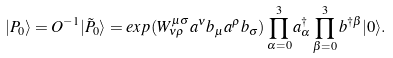Convert formula to latex. <formula><loc_0><loc_0><loc_500><loc_500>| P _ { 0 } \rangle = O ^ { - 1 } | \tilde { P } _ { 0 } \rangle = e x p ( W _ { \nu \rho } ^ { \mu \sigma } a ^ { \nu } b _ { \mu } a ^ { \rho } b _ { \sigma } ) \prod _ { \alpha = 0 } ^ { 3 } a _ { \alpha } ^ { \dagger } \prod _ { \beta = 0 } ^ { 3 } b ^ { \dagger \beta } | 0 \rangle .</formula> 